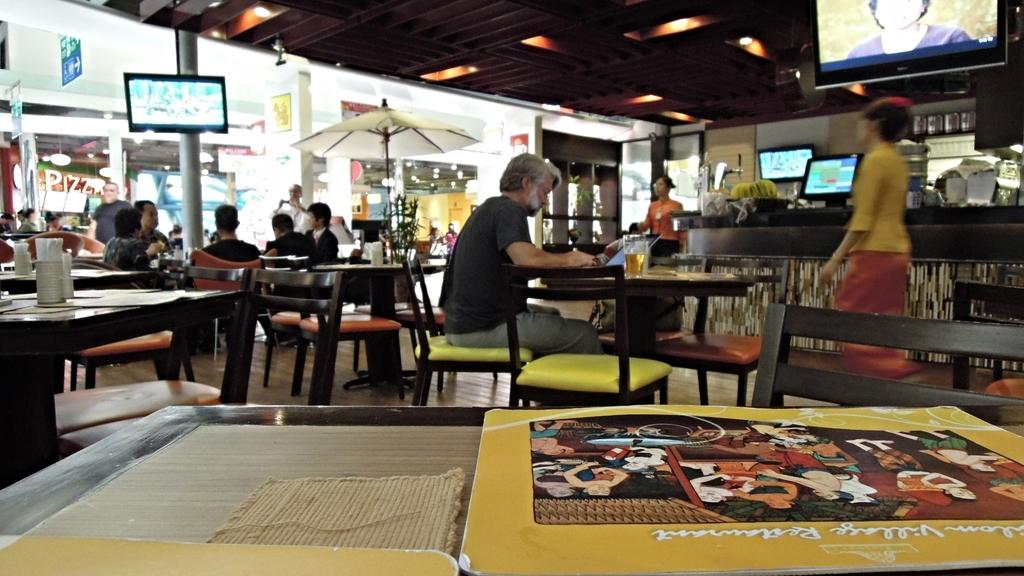Where was the image taken? The image was taken in a restaurant. What type of furniture is present in the image? There are chairs and tables in the image. Are there any people in the image? Yes, there are people in the image. What other structures can be seen in the image? There is a counter and screens in the image. Is there any outdoor element in the image? Yes, there is an umbrella in the image. What channel is the kitty watching on the screens in the image? There is no kitty present in the image, and therefore no such activity can be observed. 